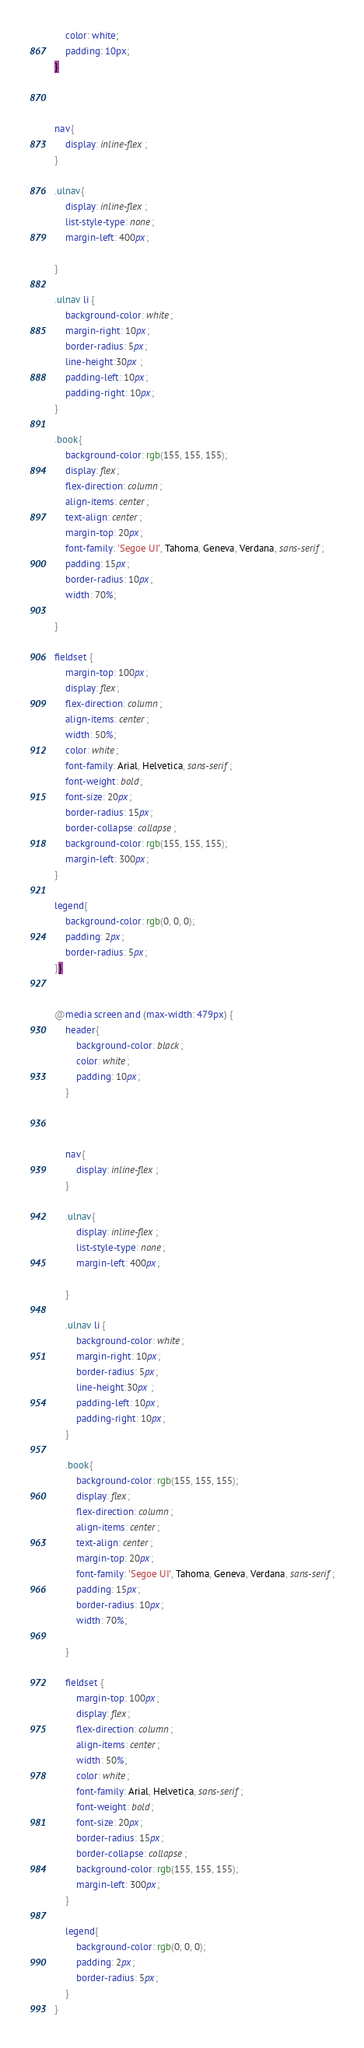<code> <loc_0><loc_0><loc_500><loc_500><_CSS_>    color: white;
    padding: 10px;
}



nav{
    display: inline-flex;
}

.ulnav{
    display: inline-flex;
    list-style-type: none;
    margin-left: 400px;
    
}

.ulnav li {
    background-color: white;
    margin-right: 10px;
    border-radius: 5px;
    line-height:30px ;
    padding-left: 10px;
    padding-right: 10px;
}

.book{
    background-color: rgb(155, 155, 155);
    display: flex;
    flex-direction: column;
    align-items: center;
    text-align: center;
    margin-top: 20px;
    font-family: 'Segoe UI', Tahoma, Geneva, Verdana, sans-serif;
    padding: 15px;
    border-radius: 10px;
    width: 70%;

}

fieldset {
    margin-top: 100px;
    display: flex;
    flex-direction: column;
    align-items: center;
    width: 50%;
    color: white;
    font-family: Arial, Helvetica, sans-serif;
    font-weight: bold;
    font-size: 20px;
    border-radius: 15px;
    border-collapse: collapse;
    background-color: rgb(155, 155, 155);
    margin-left: 300px;
}

legend{
    background-color: rgb(0, 0, 0);
    padding: 2px;
    border-radius: 5px;
}}


@media screen and (max-width: 479px) {
    header{
        background-color: black;
        color: white;
        padding: 10px;
    }
    
    
    
    nav{
        display: inline-flex;
    }
    
    .ulnav{
        display: inline-flex;
        list-style-type: none;
        margin-left: 400px;
        
    }
    
    .ulnav li {
        background-color: white;
        margin-right: 10px;
        border-radius: 5px;
        line-height:30px ;
        padding-left: 10px;
        padding-right: 10px;
    }
    
    .book{
        background-color: rgb(155, 155, 155);
        display: flex;
        flex-direction: column;
        align-items: center;
        text-align: center;
        margin-top: 20px;
        font-family: 'Segoe UI', Tahoma, Geneva, Verdana, sans-serif;
        padding: 15px;
        border-radius: 10px;
        width: 70%;
    
    }
    
    fieldset {
        margin-top: 100px;
        display: flex;
        flex-direction: column;
        align-items: center;
        width: 50%;
        color: white;
        font-family: Arial, Helvetica, sans-serif;
        font-weight: bold;
        font-size: 20px;
        border-radius: 15px;
        border-collapse: collapse;
        background-color: rgb(155, 155, 155);
        margin-left: 300px;
    }
    
    legend{
        background-color: rgb(0, 0, 0);
        padding: 2px;
        border-radius: 5px;
    }
}</code> 